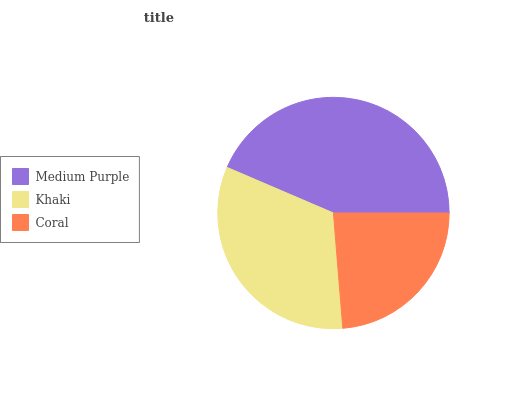Is Coral the minimum?
Answer yes or no. Yes. Is Medium Purple the maximum?
Answer yes or no. Yes. Is Khaki the minimum?
Answer yes or no. No. Is Khaki the maximum?
Answer yes or no. No. Is Medium Purple greater than Khaki?
Answer yes or no. Yes. Is Khaki less than Medium Purple?
Answer yes or no. Yes. Is Khaki greater than Medium Purple?
Answer yes or no. No. Is Medium Purple less than Khaki?
Answer yes or no. No. Is Khaki the high median?
Answer yes or no. Yes. Is Khaki the low median?
Answer yes or no. Yes. Is Coral the high median?
Answer yes or no. No. Is Medium Purple the low median?
Answer yes or no. No. 